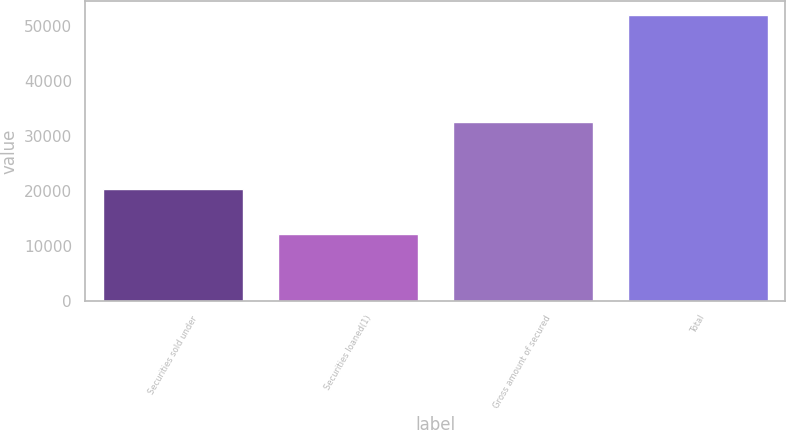Convert chart. <chart><loc_0><loc_0><loc_500><loc_500><bar_chart><fcel>Securities sold under<fcel>Securities loaned(1)<fcel>Gross amount of secured<fcel>Total<nl><fcel>20410<fcel>12247<fcel>32657<fcel>51973<nl></chart> 